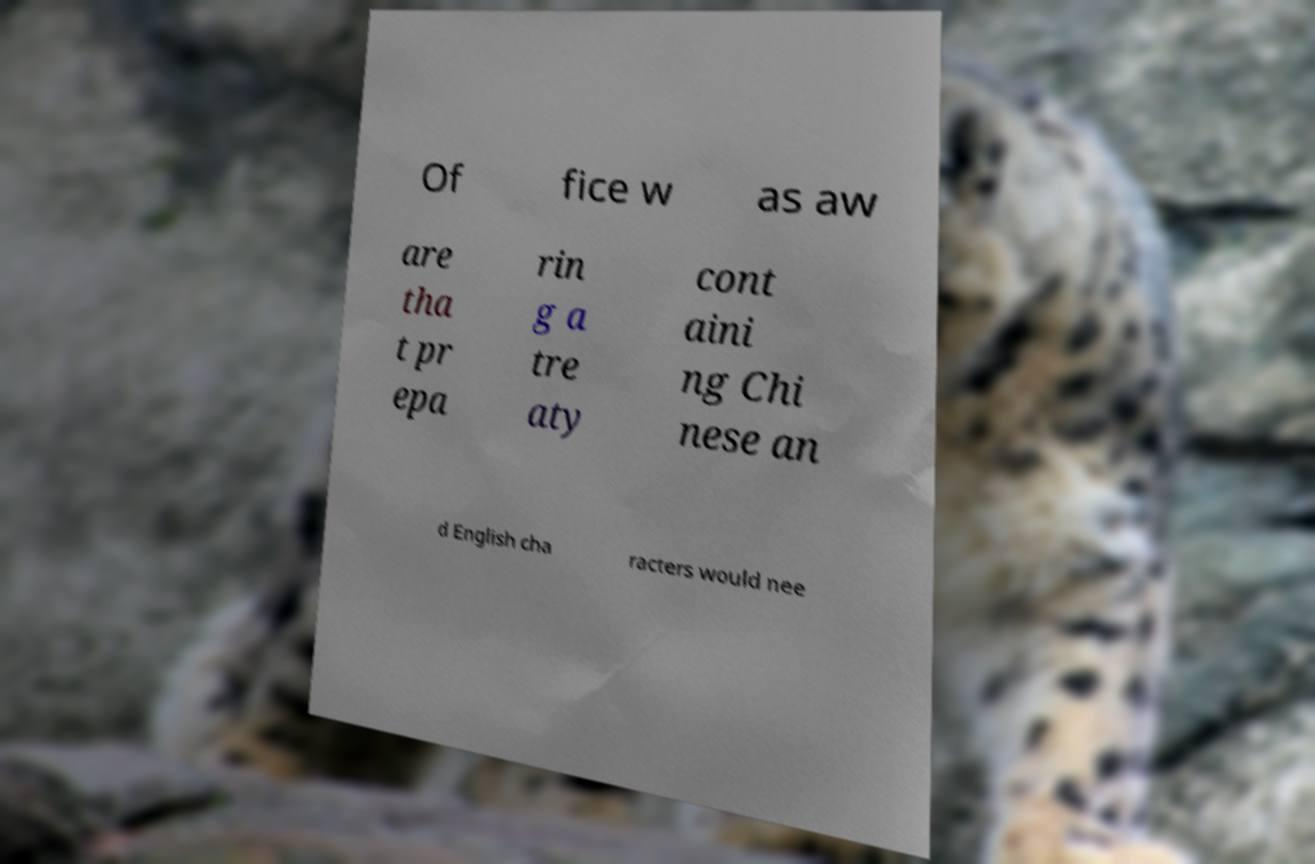What messages or text are displayed in this image? I need them in a readable, typed format. Of fice w as aw are tha t pr epa rin g a tre aty cont aini ng Chi nese an d English cha racters would nee 